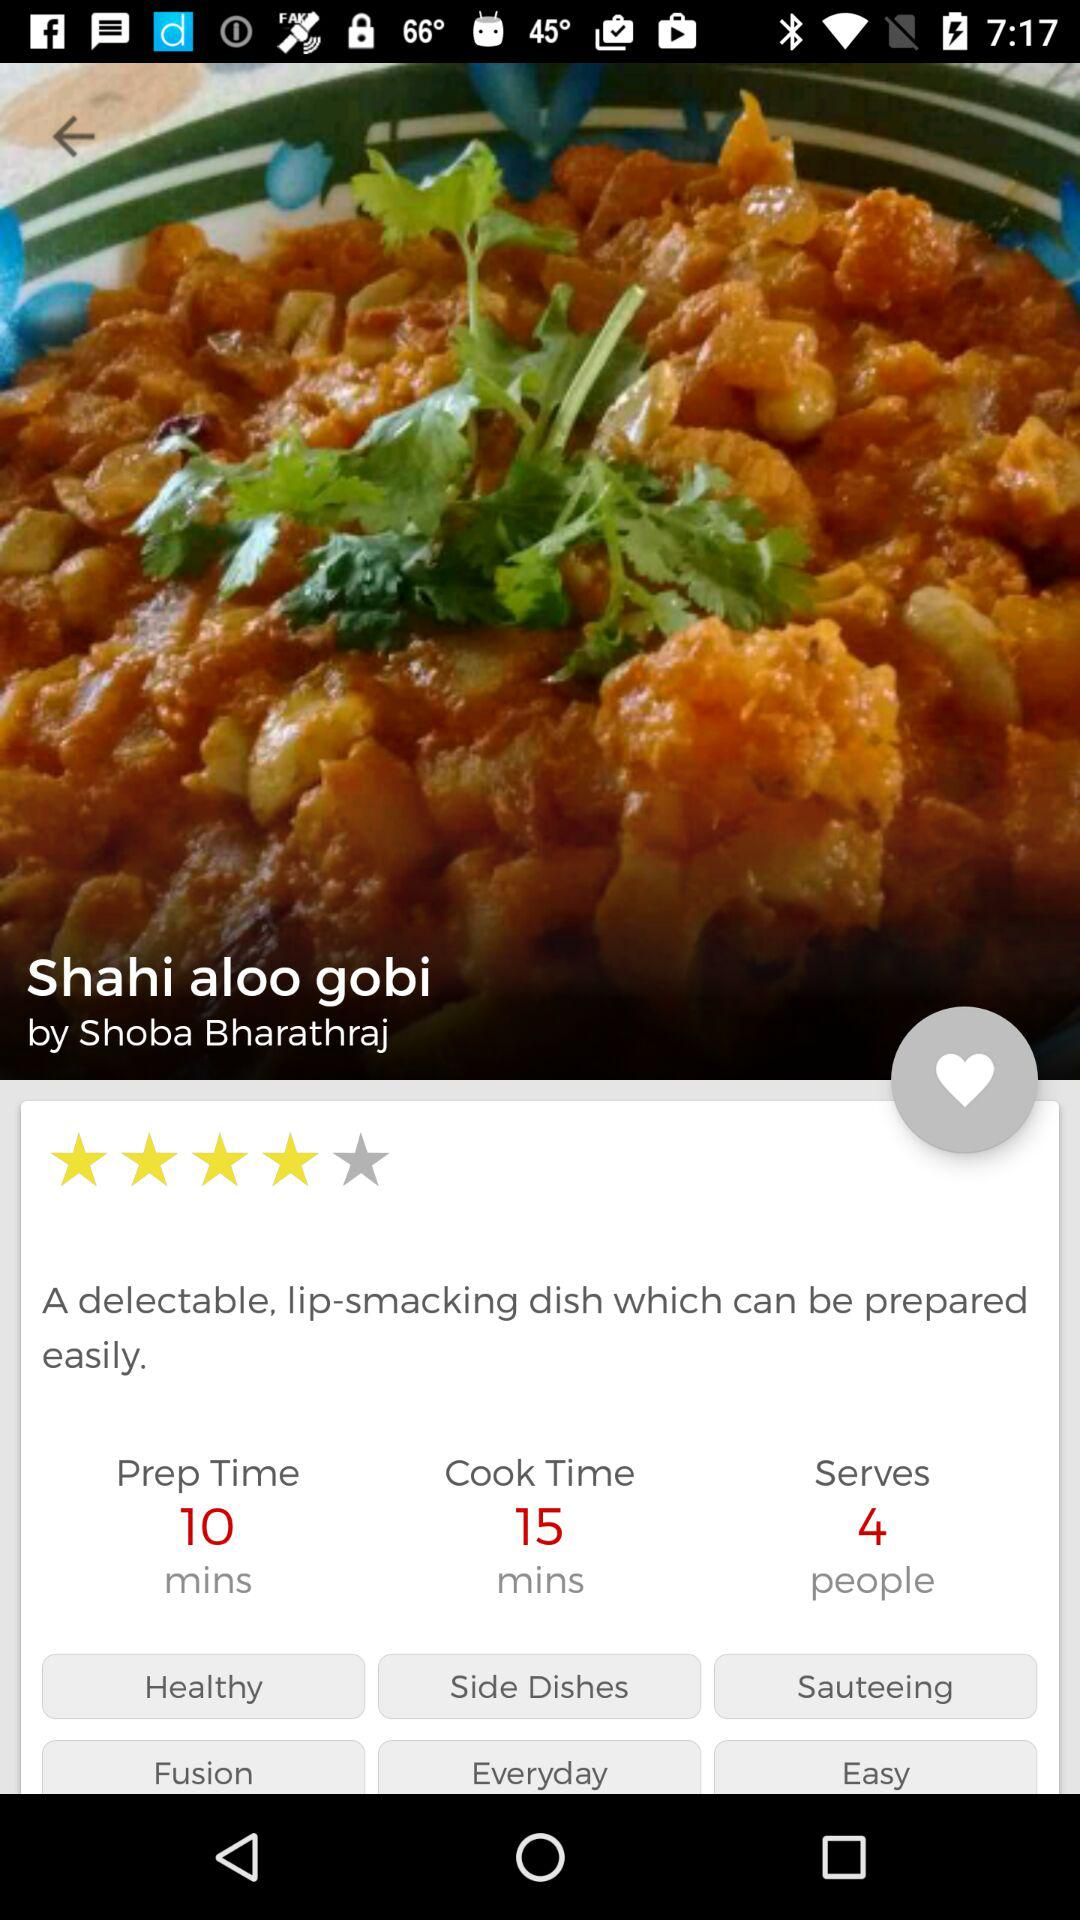How much time does it take to cook "Shahi aloo gobi"? It takes 15 minutes to cook "Shahi aloo gobi". 